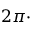Convert formula to latex. <formula><loc_0><loc_0><loc_500><loc_500>2 \pi \cdot</formula> 